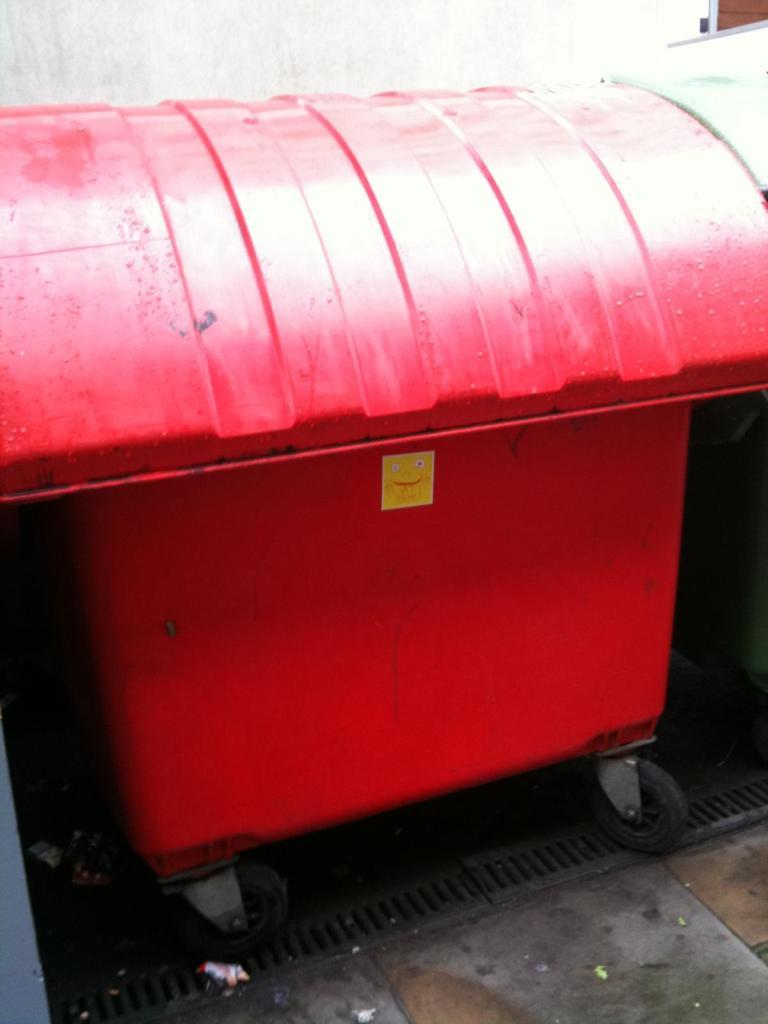What can be seen in the image? There is an object in the image. What is the color of the object? The object is red in color. What feature does the object have? The object has tires. How many pears are on the object in the image? There are no pears present in the image. Is there a rabbit sitting on the object in the image? There is no rabbit present in the image. 